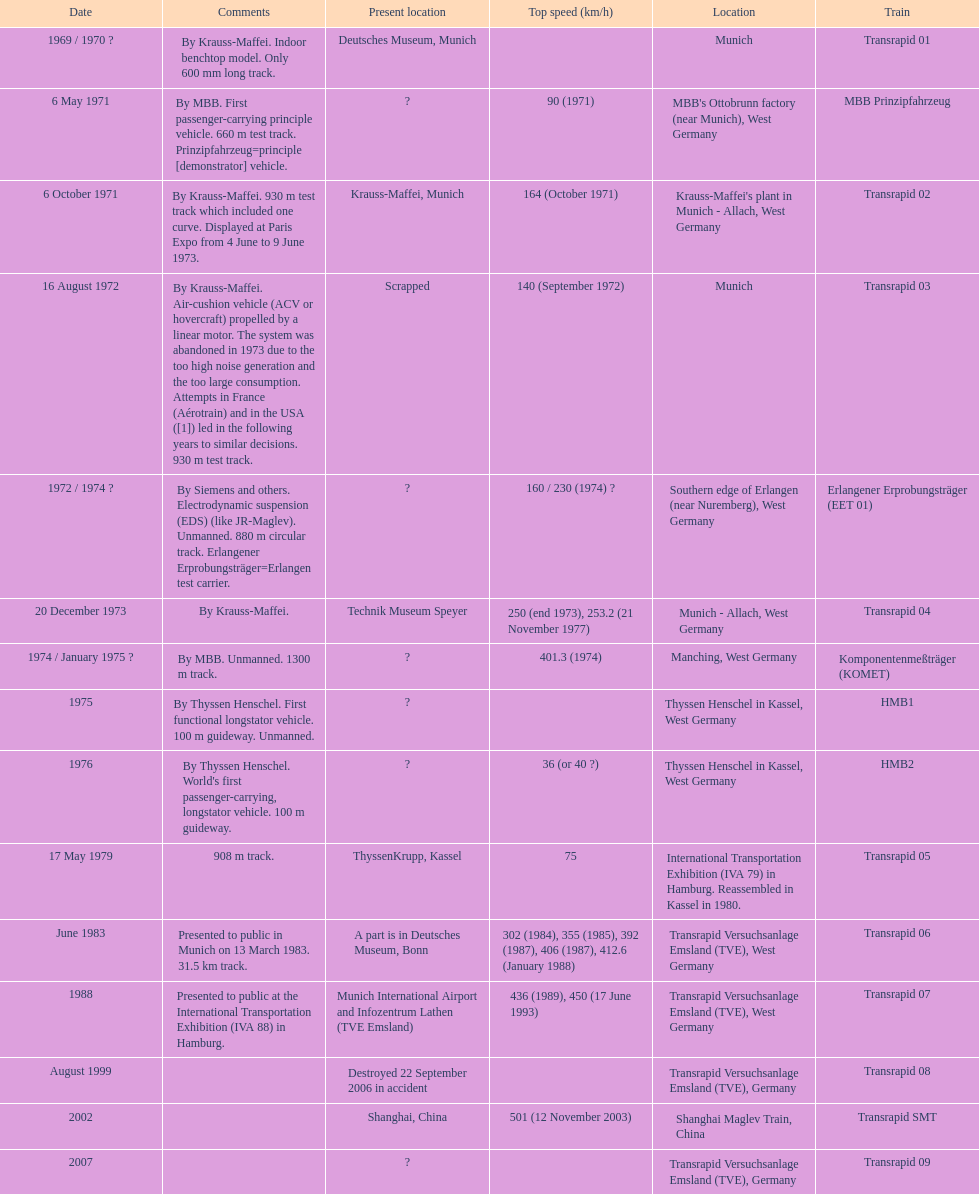How many trains listed have the same speed as the hmb2? 0. 